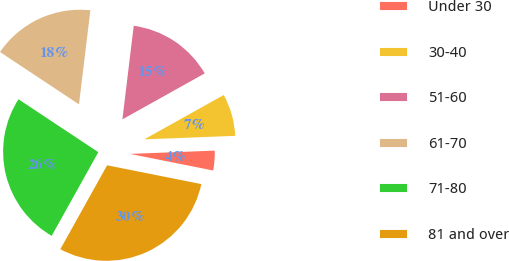<chart> <loc_0><loc_0><loc_500><loc_500><pie_chart><fcel>Under 30<fcel>30-40<fcel>51-60<fcel>61-70<fcel>71-80<fcel>81 and over<nl><fcel>3.75%<fcel>7.49%<fcel>14.98%<fcel>17.6%<fcel>26.22%<fcel>29.96%<nl></chart> 